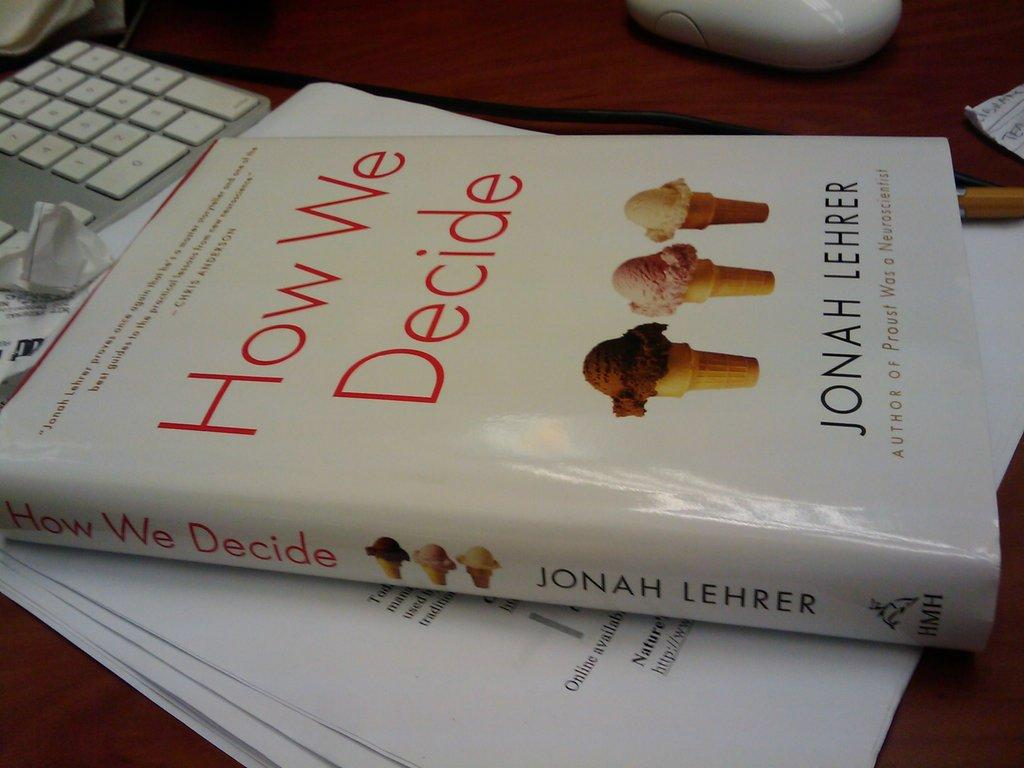<image>
Relay a brief, clear account of the picture shown. Chapter book about how we decide by Jonah Lehrer 